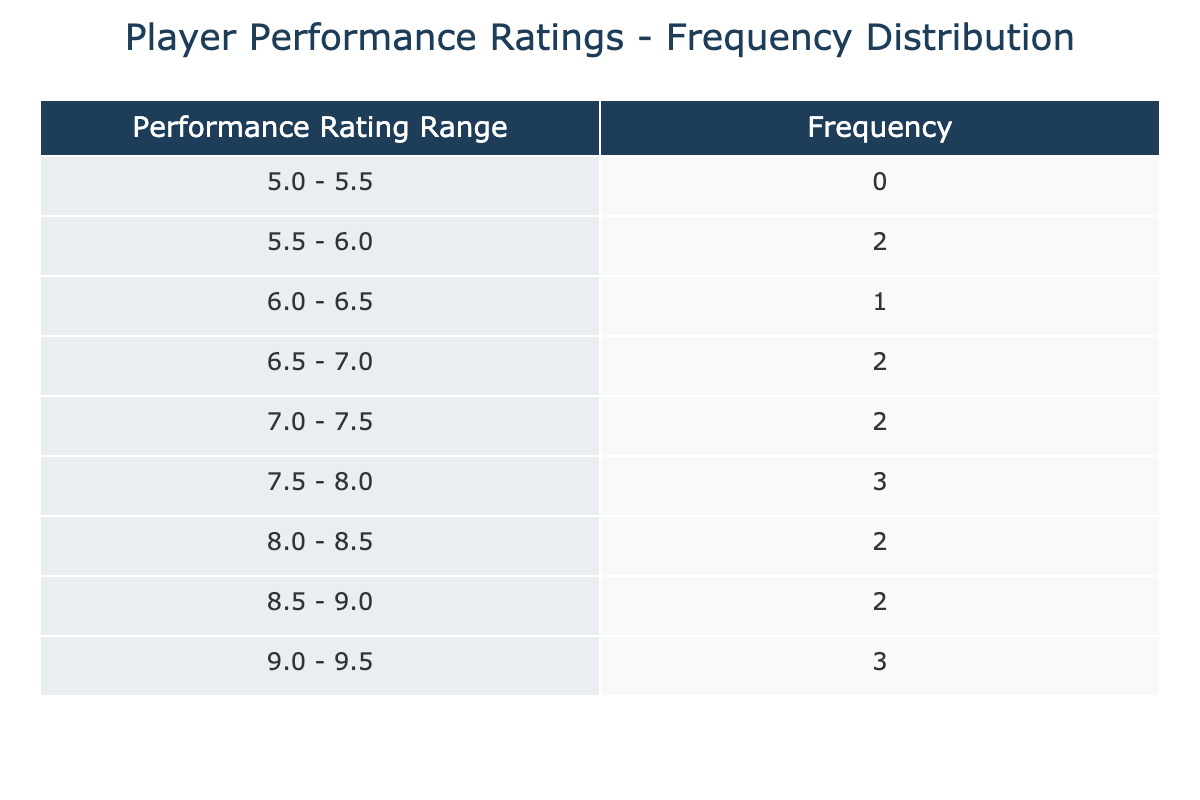What is the frequency of performance ratings between 7.5 and 8.0? To find the frequency in this range, we look at the table. The relevant bin for this range is "7.5 - 8.0", which shows a frequency of 2.
Answer: 2 Which performance rating range has the highest frequency? By examining the table, the range "7.0 - 7.5" has the highest frequency with a count of 3.
Answer: 7.0 - 7.5 Is there any player with a performance rating above 9.0? Looking at the table, there are two instances with ratings above 9.0: 9.2 and 9.3, meaning the answer is yes.
Answer: Yes What is the average performance rating within the 8.0 to 9.0 range? To find the average, we sum the performance ratings 8.1, 8.5, 8.6, 9.0, 9.2, and 9.3, which totals 51.7. There are 6 ratings, so the average is 51.7 / 6 = 8.62.
Answer: 8.62 How many players had performance ratings below 6.0? In the table, only one player falls in this category, with a rating of 5.5.
Answer: 1 How many players achieved a performance rating of 9.0 or higher? Referring to the table, there are three players with performance ratings of 9.0, 9.2, and 9.3, resulting in a count of 3 players.
Answer: 3 What is the frequency of performance ratings in the range of 6.0 to 6.5? In the table, the bin "6.0 - 6.5" shows a frequency of 1, indicating that only one player falls within this rating range.
Answer: 1 Is the average performance rating of all players less than 7.0? The sum of all performance ratings is 132.6, and there are 15 ratings, leading to an average of 132.6 / 15 = 8.84, which is greater than 7.0, so the statement is false.
Answer: No What is the performance rating range with the least frequency? By analyzing the table, the bins "5.0 - 5.5" and "9.0 - 9.5" both have a frequency of 1, indicating these ranges have the least counts.
Answer: 5.0 - 5.5 and 9.0 - 9.5 